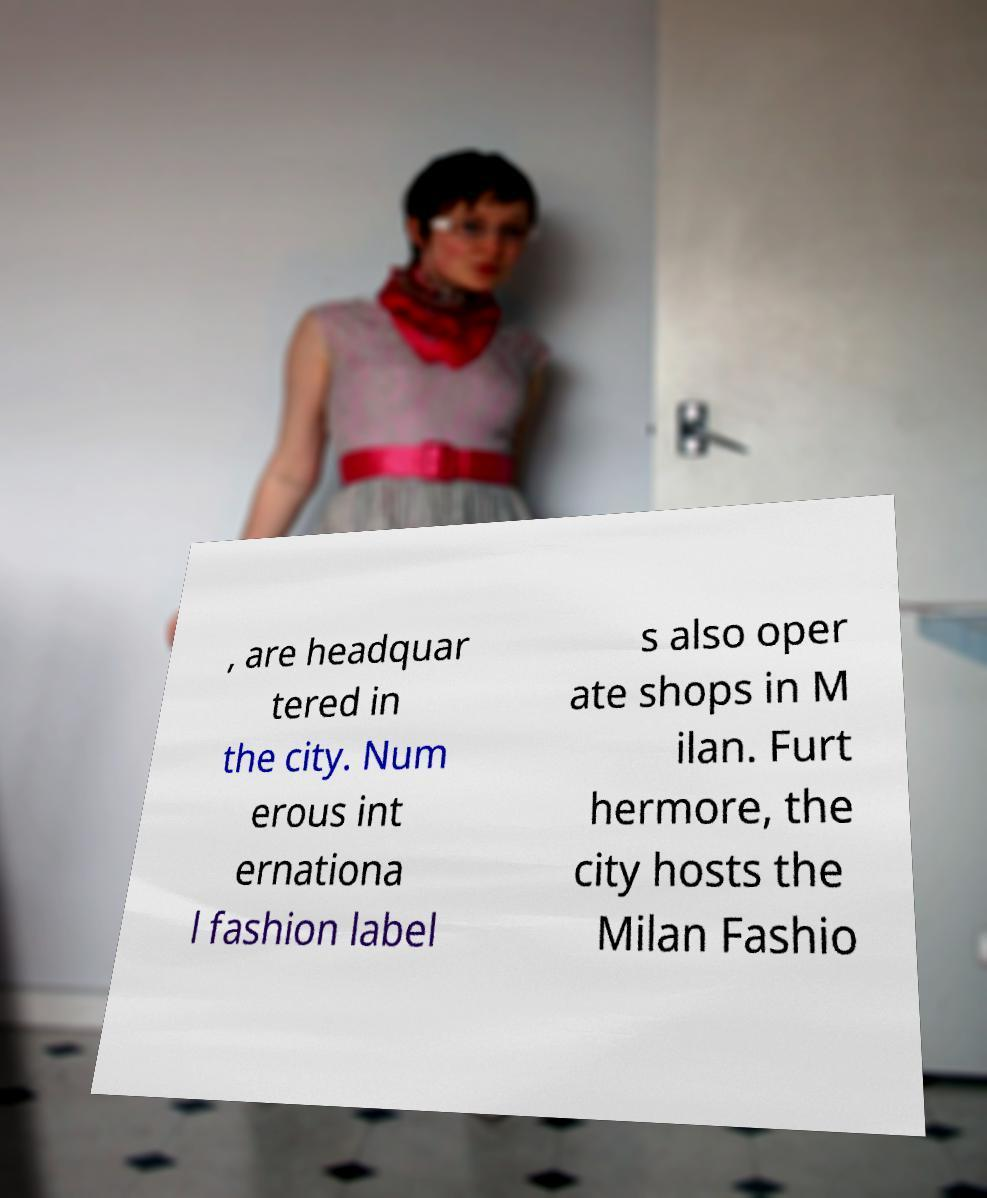Can you accurately transcribe the text from the provided image for me? , are headquar tered in the city. Num erous int ernationa l fashion label s also oper ate shops in M ilan. Furt hermore, the city hosts the Milan Fashio 